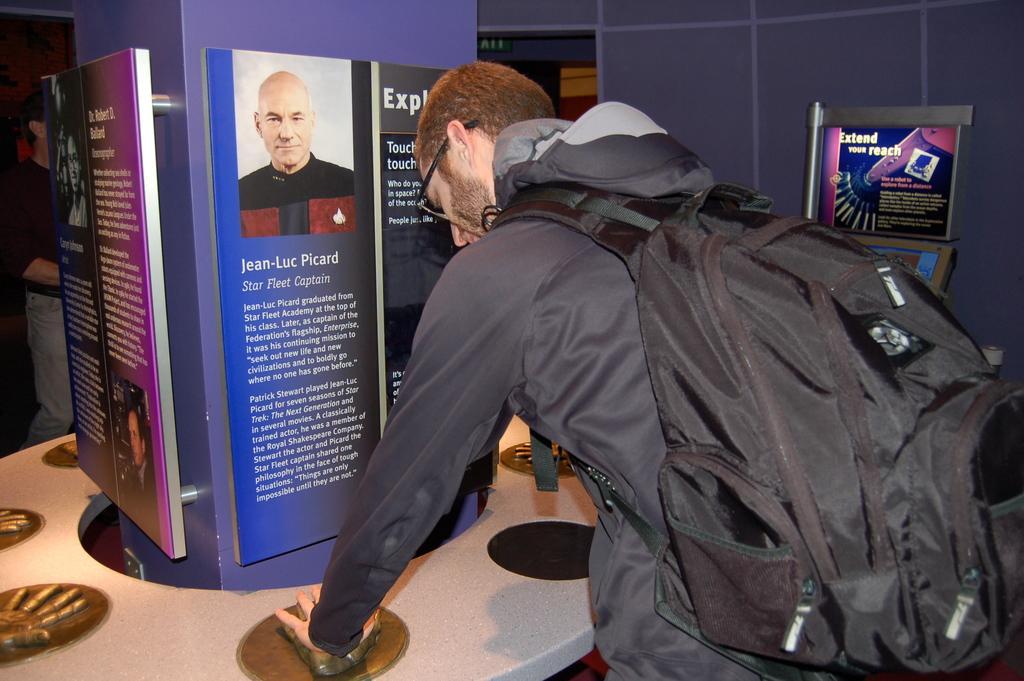Can you describe this image briefly? In the image there is man wearing a bag printing his hand on a mould , in front of him there is a banner. 